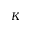<formula> <loc_0><loc_0><loc_500><loc_500>K</formula> 